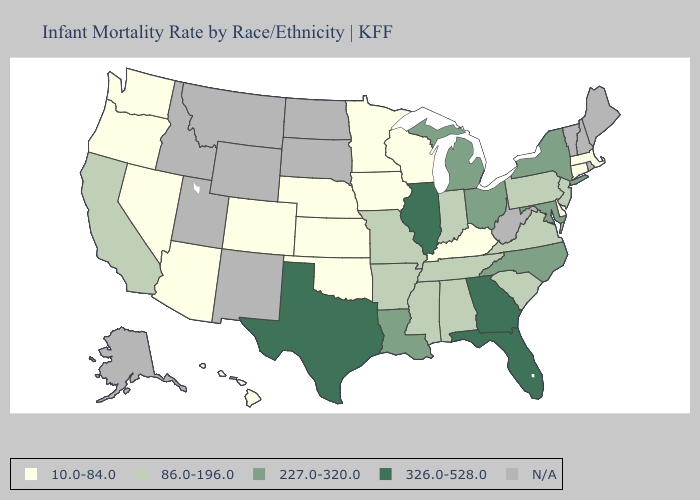What is the value of Iowa?
Answer briefly. 10.0-84.0. Does Kentucky have the highest value in the USA?
Write a very short answer. No. Among the states that border New Jersey , which have the lowest value?
Keep it brief. Delaware. Name the states that have a value in the range 86.0-196.0?
Be succinct. Alabama, Arkansas, California, Indiana, Mississippi, Missouri, New Jersey, Pennsylvania, South Carolina, Tennessee, Virginia. What is the value of Washington?
Short answer required. 10.0-84.0. Name the states that have a value in the range 86.0-196.0?
Concise answer only. Alabama, Arkansas, California, Indiana, Mississippi, Missouri, New Jersey, Pennsylvania, South Carolina, Tennessee, Virginia. Name the states that have a value in the range 227.0-320.0?
Concise answer only. Louisiana, Maryland, Michigan, New York, North Carolina, Ohio. Name the states that have a value in the range N/A?
Answer briefly. Alaska, Idaho, Maine, Montana, New Hampshire, New Mexico, North Dakota, Rhode Island, South Dakota, Utah, Vermont, West Virginia, Wyoming. What is the lowest value in states that border Mississippi?
Concise answer only. 86.0-196.0. What is the highest value in the Northeast ?
Be succinct. 227.0-320.0. Name the states that have a value in the range 326.0-528.0?
Be succinct. Florida, Georgia, Illinois, Texas. What is the lowest value in the USA?
Short answer required. 10.0-84.0. Name the states that have a value in the range 326.0-528.0?
Answer briefly. Florida, Georgia, Illinois, Texas. Name the states that have a value in the range 86.0-196.0?
Keep it brief. Alabama, Arkansas, California, Indiana, Mississippi, Missouri, New Jersey, Pennsylvania, South Carolina, Tennessee, Virginia. What is the highest value in the South ?
Short answer required. 326.0-528.0. 